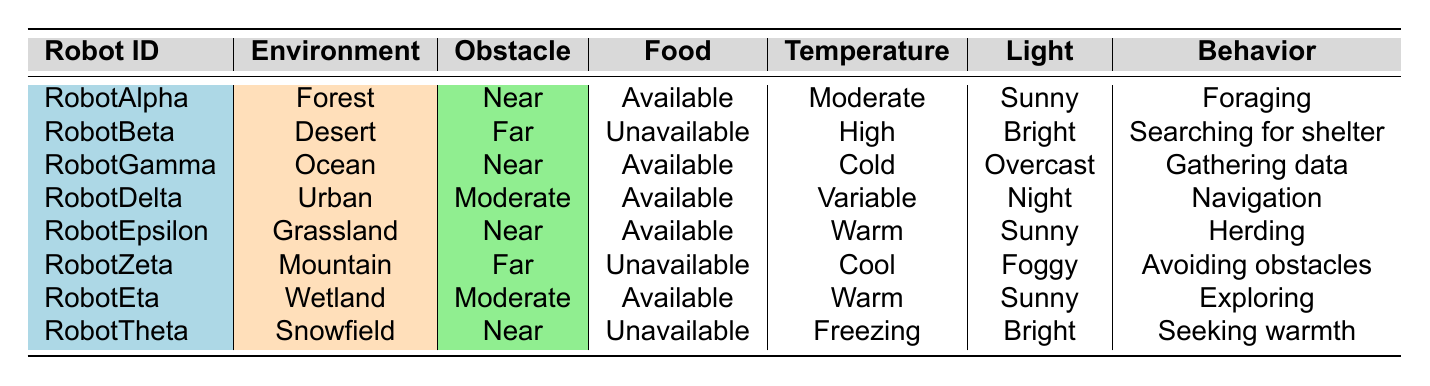What behavior does RobotAlpha exhibit? According to the table, RobotAlpha is in the Forest environment, experiences a Near distance to an obstacle, has an Available food source, and is under Moderate temperature and Sunny light conditions. Its behavior is labeled as Foraging.
Answer: Foraging Which robot is associated with Avoiding obstacles behavior? The table shows that RobotZeta, located in the Mountain environment with a Far distance to an obstacle and an Unavailable food source, exhibits the behavior of Avoiding obstacles.
Answer: RobotZeta How many robots are classified as searching for shelter? The table provides one entry, RobotBeta, which is in the Desert environment and has the behavior of Searching for shelter. Thus, there is only one robot in this category.
Answer: One Is the food source available for RobotGamma? The table indicates that RobotGamma is in the Ocean environment and has an Available food source. Therefore, the answer is true.
Answer: Yes What is the relationship between light conditions and the behaviors of robots in the table? Analyzing the light conditions in the table, we see that RobotAlpha, RobotEpsilon, and RobotEta, all in environments with Sunny conditions, exhibit behaviors related to Foraging, Herding, and Exploring. Conversely, RobotDelta operates under Night conditions for Navigation, and RobotTheta displays Seeking warmth under Bright light. This suggests no direct correlation but suggests preferences for specific behaviors under varying light conditions.
Answer: No clear relationship Which robot operates in the hottest environment? From the table, we can observe that RobotBeta, in the Desert with High temperature, operates in the hottest environment compared to others.
Answer: RobotBeta What behaviors do robots exhibit when facing a Near distance to an obstacle? Looking at the data, RobotAlpha (Foraging), RobotGamma (Gathering data), RobotEpsilon (Herding), and RobotTheta (Seeking warmth) are all exhibiting behaviors while being at a Near distance to an obstacle. Thus, there are four distinct behaviors for the robots under this condition.
Answer: Four behaviors What is the average temperature for robots with an Available food source? The robots with Available food sources are RobotAlpha (Moderate), RobotGamma (Cold), RobotDelta (Variable), RobotEpsilon (Warm), and RobotEta (Warm). Converting the qualitative temperatures gives an approximate numeric value: Moderate (20°C), Cold (5°C), Variable (15°C), Warm (25°C), Warm (25°C). The average temperature = (20 + 5 + 15 + 25 + 25) / 5 = 18.
Answer: 18 How many robots have a distance to an obstacle that is Far? By checking the table, both RobotBeta and RobotZeta are classified with a distance to obstacles as Far, leading to a total of two robots.
Answer: Two 